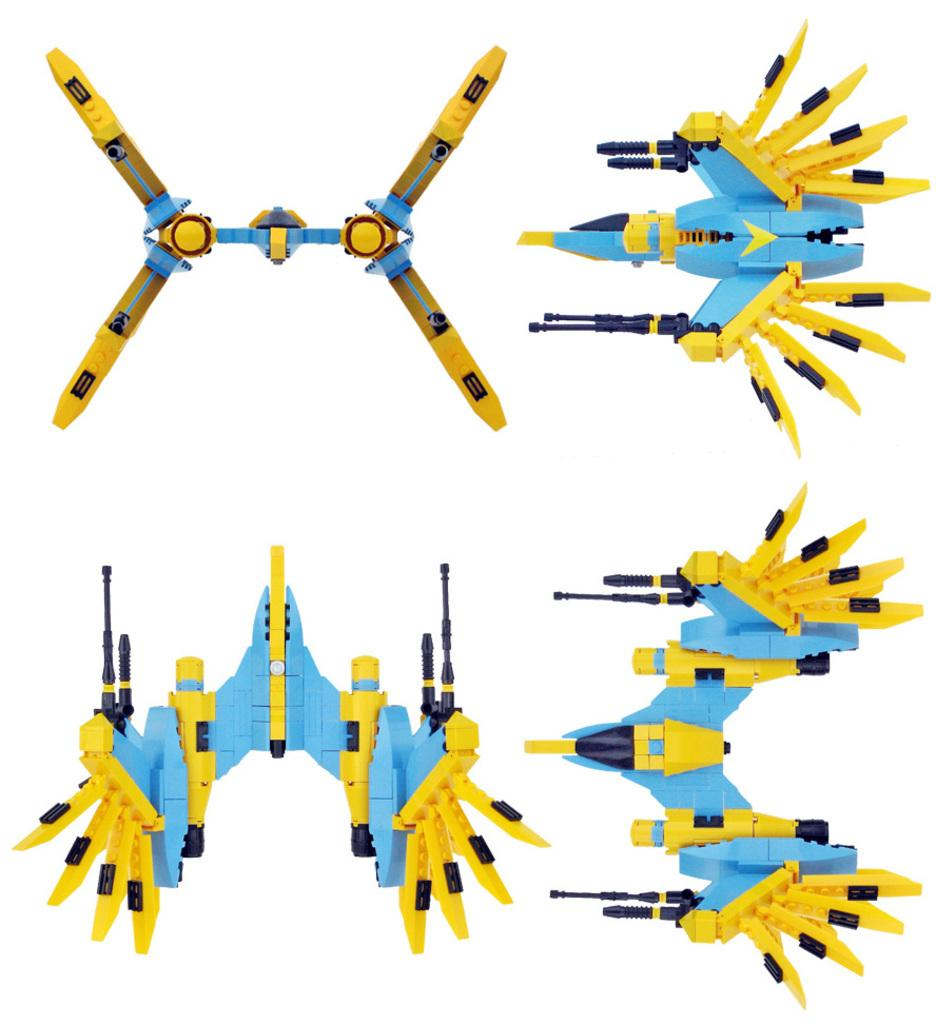How many dolls are present in the image? There are four dolls in the image. Can you describe the colors of the dolls? Two of the dolls are yellow, and two are blue. What type of flower is growing next to the blue dolls in the image? There is no flower present in the image; it only features four dolls. 